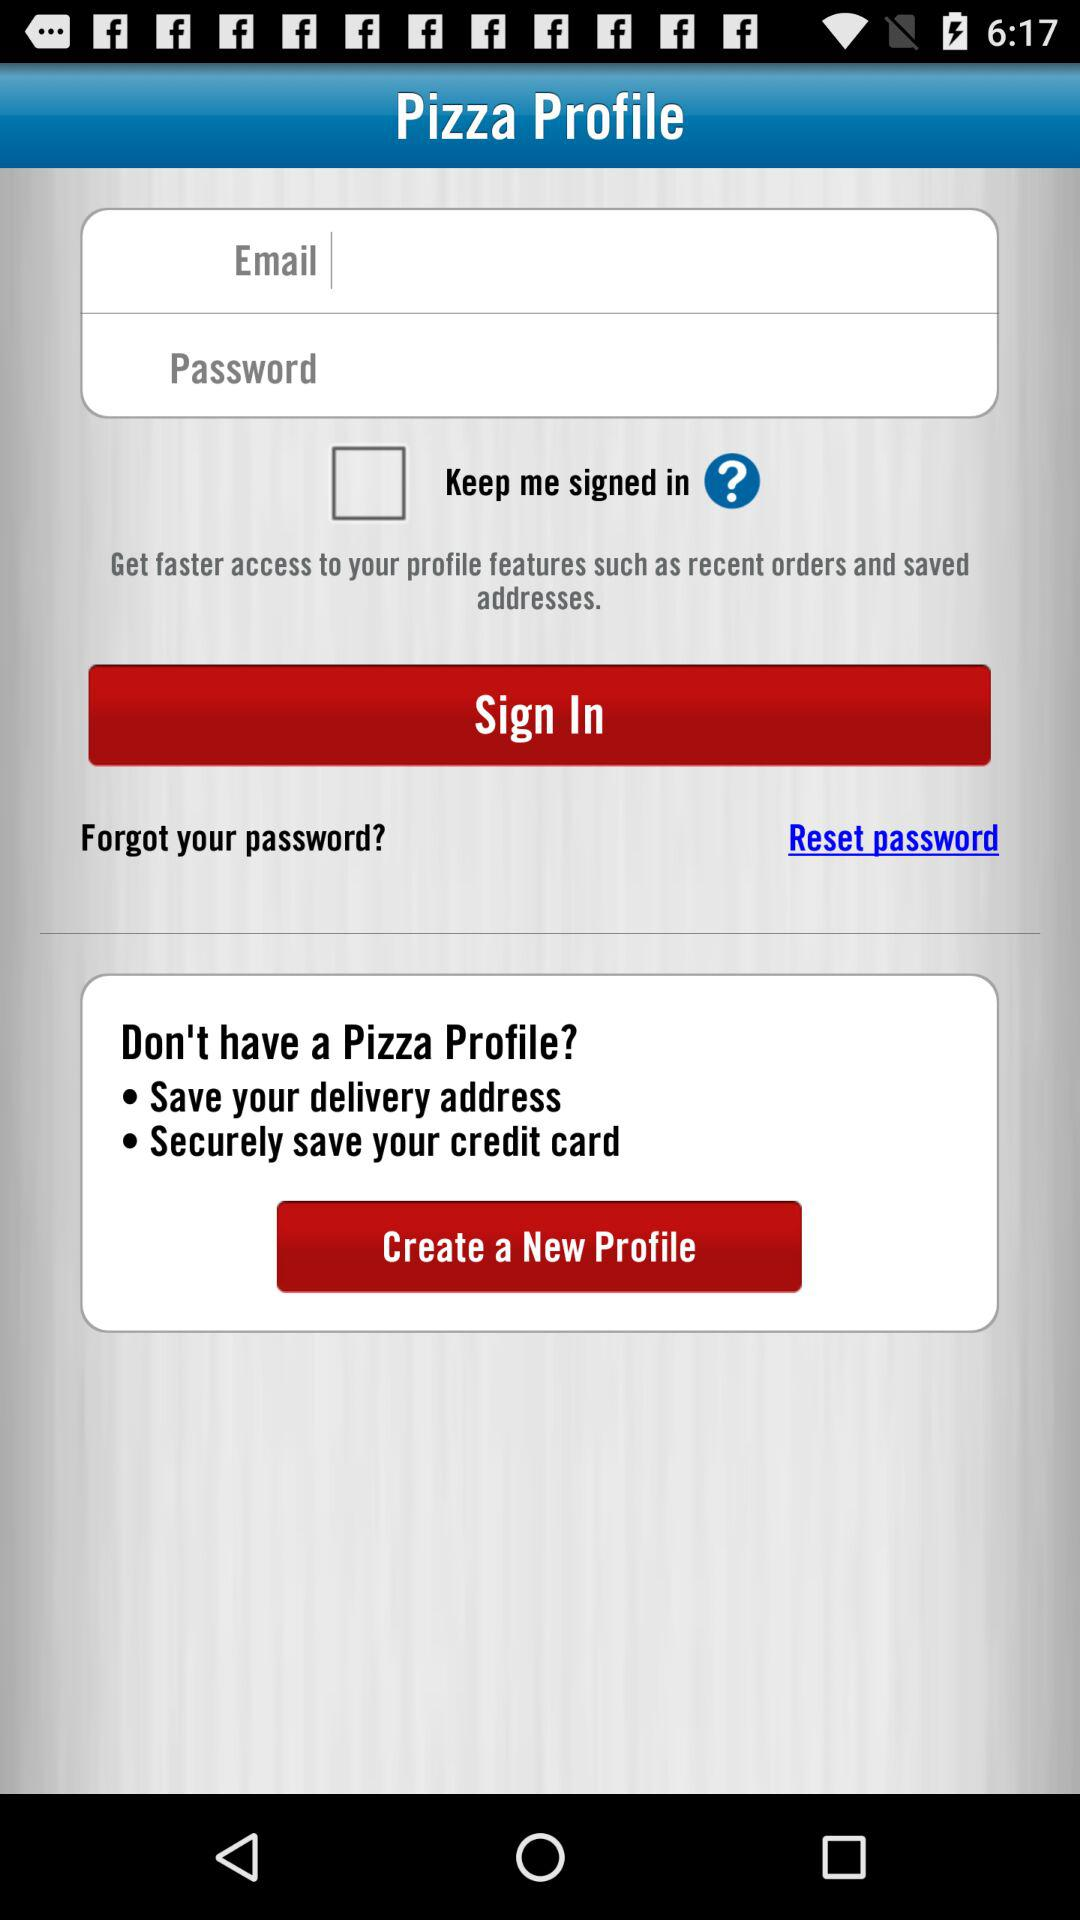What is the application name? The application name is "Pizza Profile". 